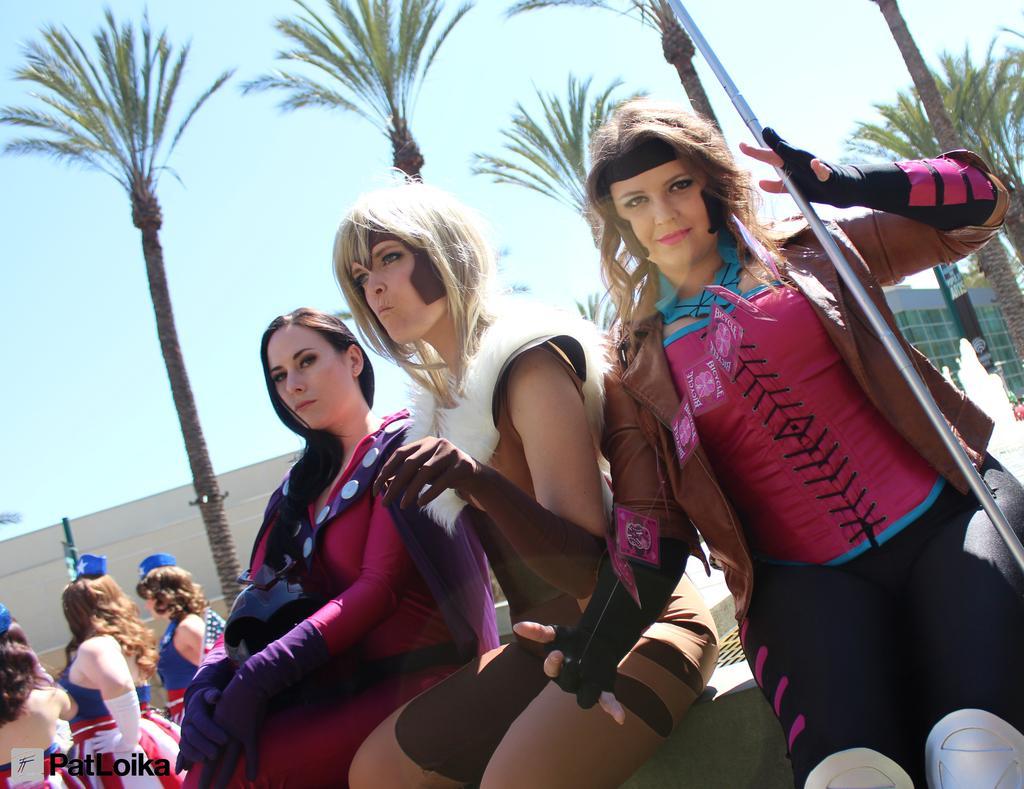In one or two sentences, can you explain what this image depicts? In this picture i can see a few women Standing and few are seated and we see trees and buildings and few of them wore caps on their heads and a woman holding a metal rod and i can see a blue cloudy Sky and we see text at the bottom left corner of the picture. 